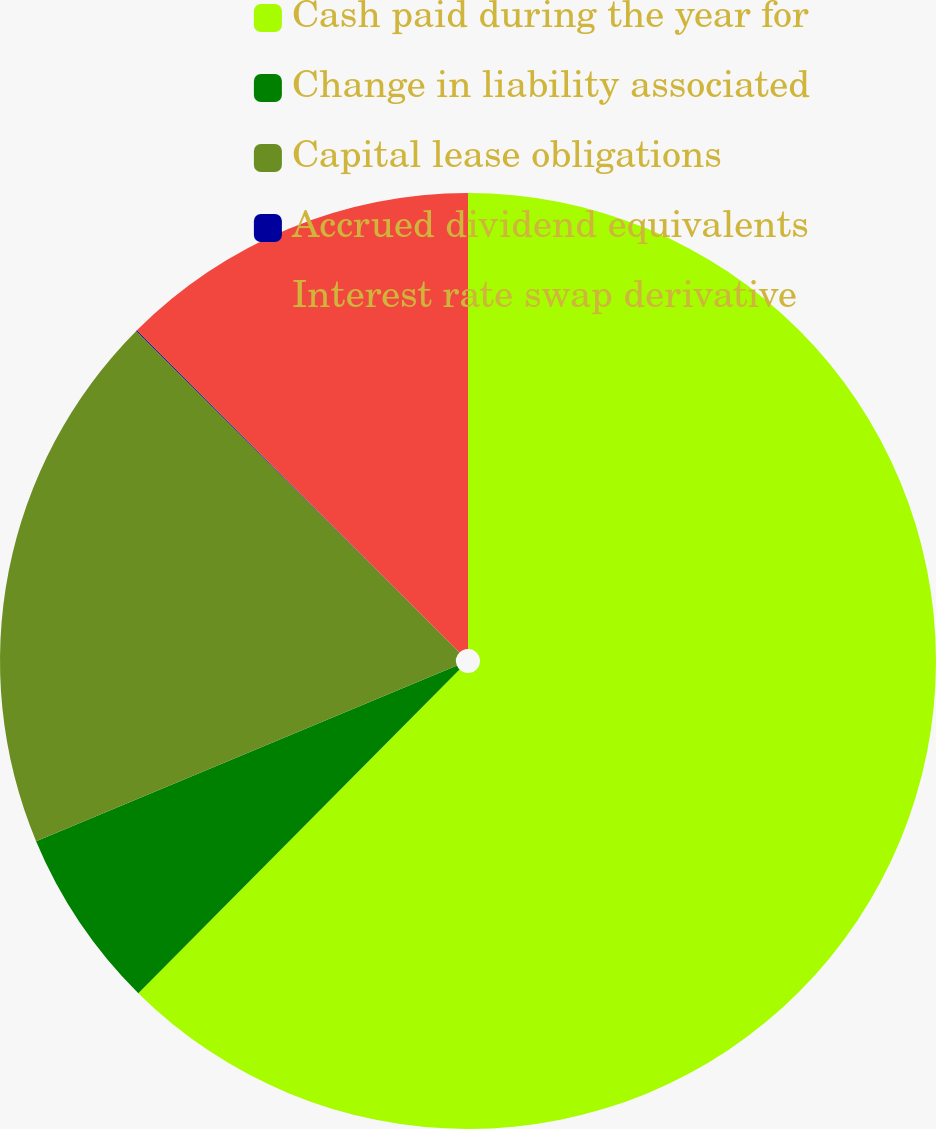Convert chart to OTSL. <chart><loc_0><loc_0><loc_500><loc_500><pie_chart><fcel>Cash paid during the year for<fcel>Change in liability associated<fcel>Capital lease obligations<fcel>Accrued dividend equivalents<fcel>Interest rate swap derivative<nl><fcel>62.44%<fcel>6.27%<fcel>18.75%<fcel>0.03%<fcel>12.51%<nl></chart> 